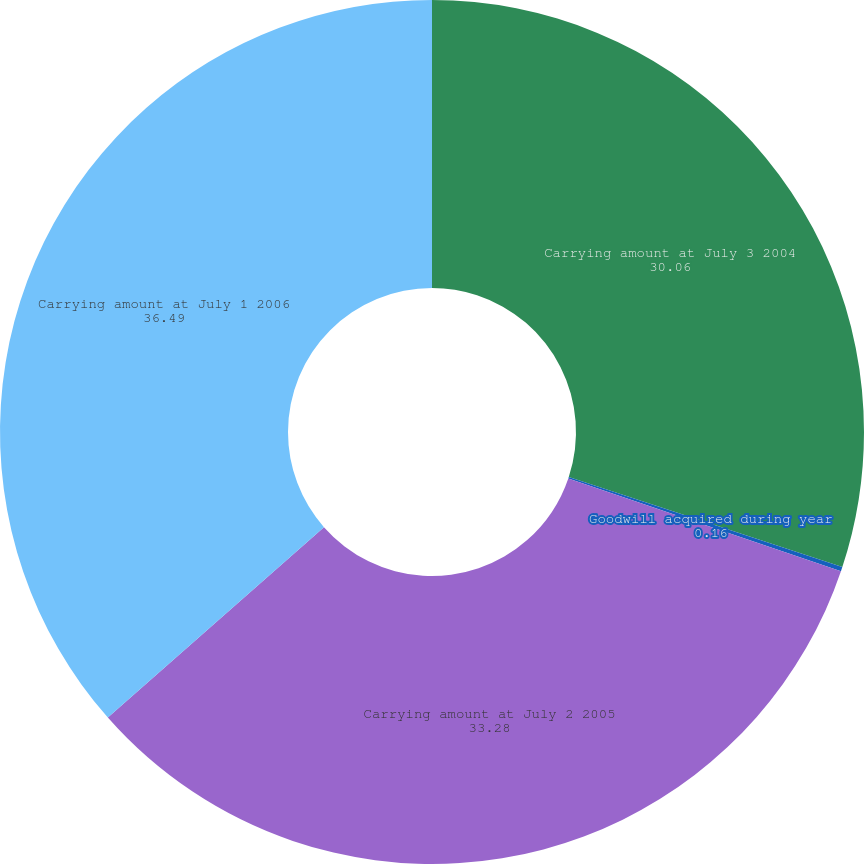<chart> <loc_0><loc_0><loc_500><loc_500><pie_chart><fcel>Carrying amount at July 3 2004<fcel>Goodwill acquired during year<fcel>Carrying amount at July 2 2005<fcel>Carrying amount at July 1 2006<nl><fcel>30.06%<fcel>0.16%<fcel>33.28%<fcel>36.49%<nl></chart> 